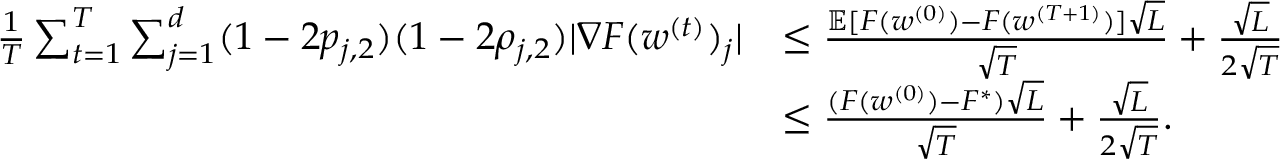Convert formula to latex. <formula><loc_0><loc_0><loc_500><loc_500>\begin{array} { r l } { \frac { 1 } { T } \sum _ { t = 1 } ^ { T } \sum _ { j = 1 } ^ { d } ( 1 - 2 p _ { j , 2 } ) ( 1 - 2 \rho _ { j , 2 } ) | \nabla F ( w ^ { ( t ) } ) _ { j } | } & { \leq \frac { \mathbb { E } [ F ( w ^ { ( 0 ) } ) - F ( w ^ { ( T + 1 ) } ) ] \sqrt { L } } { \sqrt { T } } + \frac { \sqrt { L } } { 2 \sqrt { T } } } \\ & { \leq \frac { ( F ( w ^ { ( 0 ) } ) - F ^ { * } ) \sqrt { L } } { \sqrt { T } } + \frac { \sqrt { L } } { 2 \sqrt { T } } . } \end{array}</formula> 